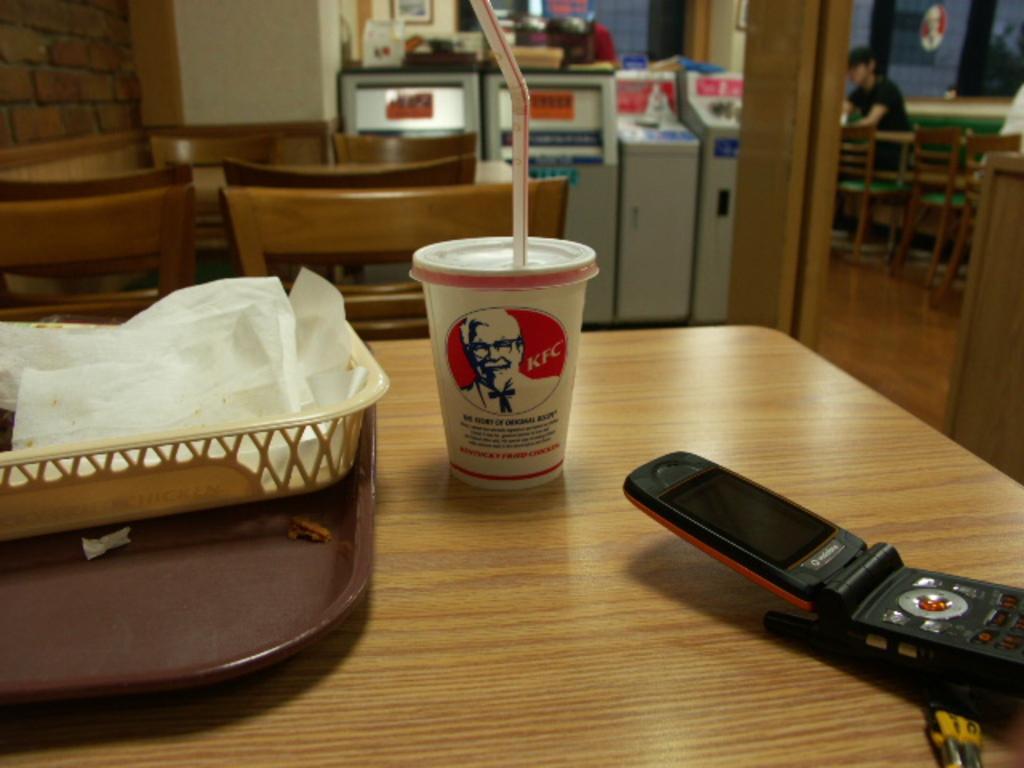Can you describe this image briefly? In the image we can see on the table there is juice glass, mobile phone and tissue papers kept in the basket. There are chairs and there is a person sitting on the chair. 